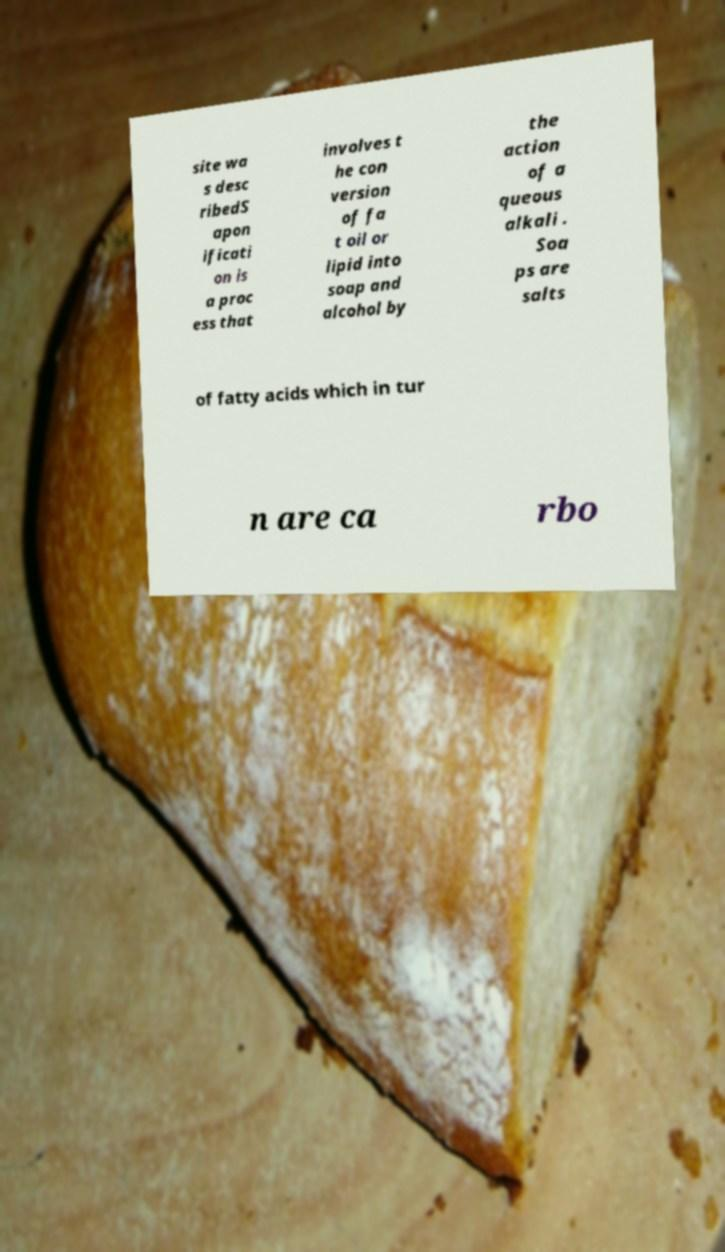Please identify and transcribe the text found in this image. site wa s desc ribedS apon ificati on is a proc ess that involves t he con version of fa t oil or lipid into soap and alcohol by the action of a queous alkali . Soa ps are salts of fatty acids which in tur n are ca rbo 